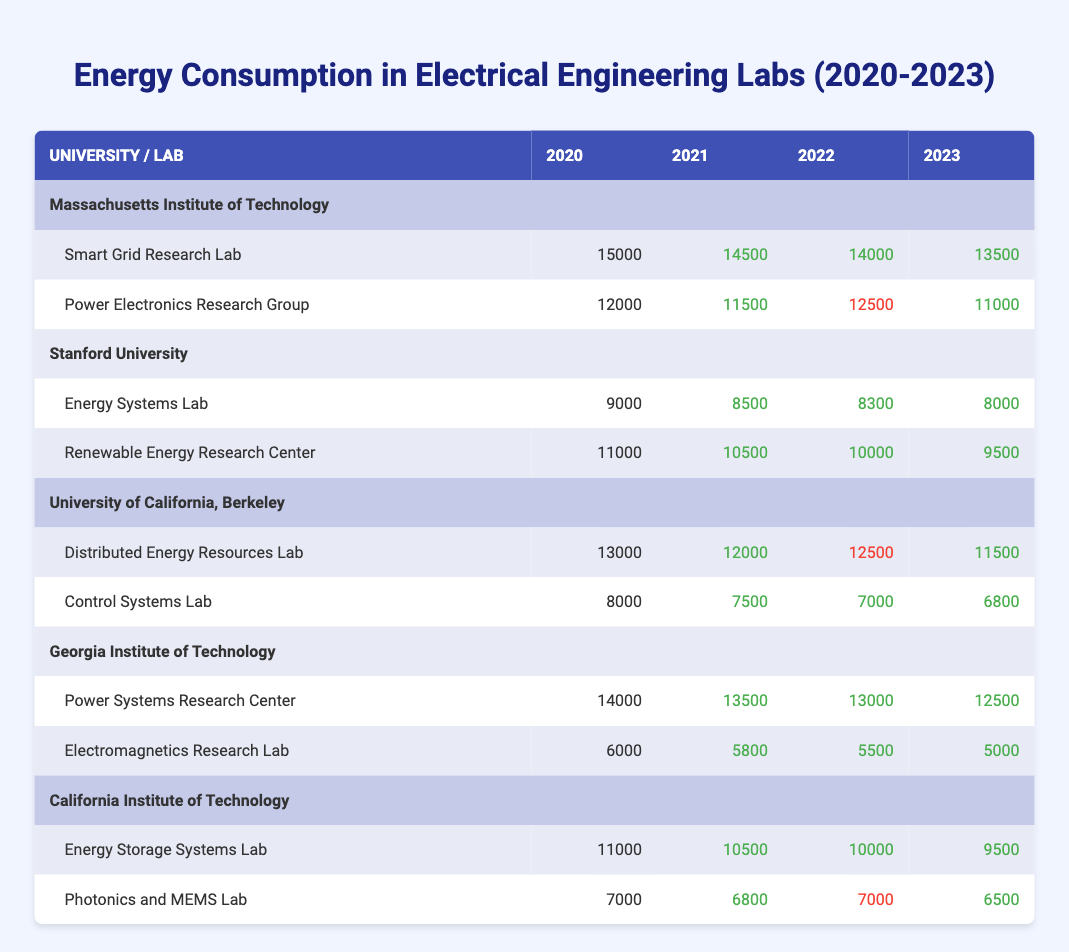What was the energy consumption of the Smart Grid Research Lab in 2021? The table shows the energy consumption for the Smart Grid Research Lab for each year. In 2021, it consumed 14500.
Answer: 14500 Which lab had the lowest energy consumption in 2023? In 2023, the labs' energy consumptions are as follows: Smart Grid Research Lab (13500), Power Electronics Research Group (11000), Energy Systems Lab (8000), Renewable Energy Research Center (9500), Distributed Energy Resources Lab (11500), Control Systems Lab (6800), Power Systems Research Center (12500), Electromagnetics Research Lab (5000), Energy Storage Systems Lab (9500), Photonics and MEMS Lab (6500). The Electromagnetics Research Lab has the lowest value of 5000.
Answer: Electromagnetics Research Lab What is the total energy consumption of the Power Electronics Research Group from 2020 to 2023? The energy consumption for the Power Electronics Research Group for each year is: 12000 (2020) + 11500 (2021) + 12500 (2022) + 11000 (2023). Adding these values gives 12000 + 11500 + 12500 + 11000 = 47000.
Answer: 47000 Did the energy consumption of the Control Systems Lab decrease every year from 2020 to 2023? The energy values for the Control Systems Lab are: 8000 (2020), 7500 (2021), 7000 (2022), and 6800 (2023). Each year shows a decrease from one year to the next, confirming a consistent decline.
Answer: Yes Which university had the highest average energy consumption across all its labs in 2022? Calculate the average energy consumption for labs in each university for 2022: MIT: (14000 + 12500) / 2 = 13250; Stanford: (8300 + 10000) / 2 = 9150; UC Berkeley: (12500 + 7000) / 2 = 9750; Georgia Tech: (13000 + 5500) / 2 = 9250; Caltech: (10000 + 7000) / 2 = 8500. The highest average is from MIT with 13250.
Answer: Massachusetts Institute of Technology What was the trend of energy consumption in the Energy Systems Lab over the years? The energy consumptions for the Energy Systems Lab are: 9000 (2020), 8500 (2021), 8300 (2022), and 8000 (2023). Each subsequent year shows a decrease.
Answer: Decreasing What is the difference in energy consumption between Georgia Institute of Technology's labs in 2020? The energy consumption in 2020 for the Power Systems Research Center is 14000 and for the Electromagnetics Research Lab is 6000. The difference is calculated as 14000 - 6000 = 8000.
Answer: 8000 In which year did the Distributed Energy Resources Lab have its highest energy consumption? Referring to the table, the values for the Distributed Energy Resources Lab are: 13000 (2020), 12000 (2021), 12500 (2022), and 11500 (2023). The highest value recorded is in 2020 at 13000.
Answer: 2020 Which lab showed an increase in energy consumption between 2021 and 2022? The only lab that showed an increase is the Power Electronics Research Group, which increased from 11500 in 2021 to 12500 in 2022. All others showed a decrease.
Answer: Power Electronics Research Group 